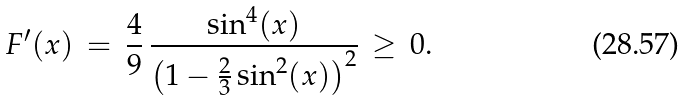Convert formula to latex. <formula><loc_0><loc_0><loc_500><loc_500>F ^ { \prime } ( x ) \, = \, \frac { 4 } { 9 } \, \frac { \sin ^ { 4 } ( x ) } { \left ( 1 - \frac { 2 } { 3 } \sin ^ { 2 } ( x ) \right ) ^ { 2 } } \, \geq \, 0 .</formula> 